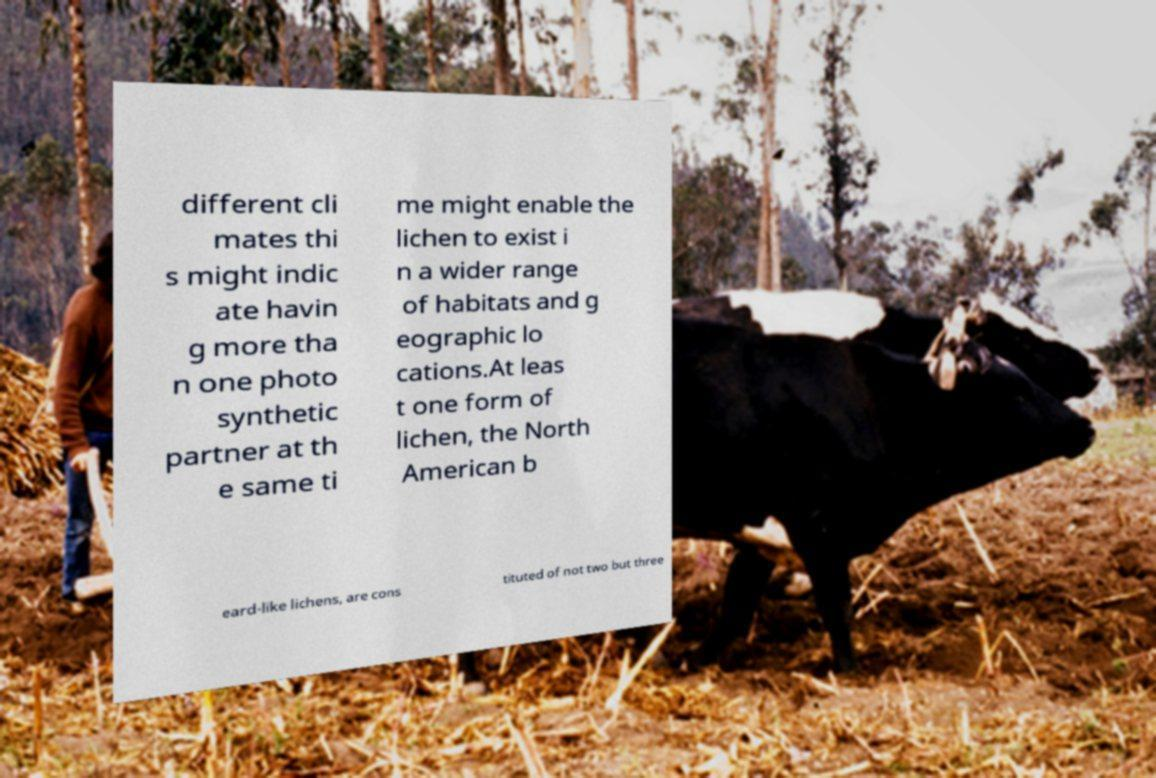For documentation purposes, I need the text within this image transcribed. Could you provide that? different cli mates thi s might indic ate havin g more tha n one photo synthetic partner at th e same ti me might enable the lichen to exist i n a wider range of habitats and g eographic lo cations.At leas t one form of lichen, the North American b eard-like lichens, are cons tituted of not two but three 